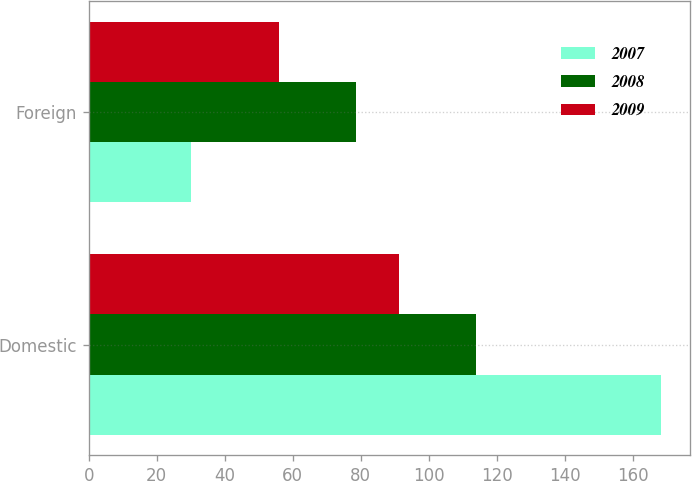Convert chart to OTSL. <chart><loc_0><loc_0><loc_500><loc_500><stacked_bar_chart><ecel><fcel>Domestic<fcel>Foreign<nl><fcel>2007<fcel>168.4<fcel>30<nl><fcel>2008<fcel>113.9<fcel>78.7<nl><fcel>2009<fcel>91.4<fcel>55.9<nl></chart> 